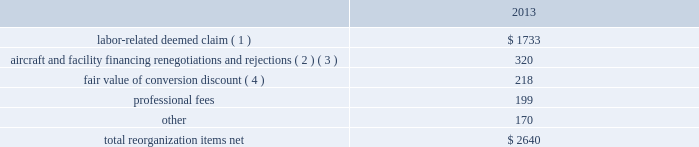Table of contents interest expense , net of capitalized interest decreased $ 129 million , or 18.1% ( 18.1 % ) , in 2014 from the 2013 period primarily due to a $ 63 million decrease in special charges recognized period-over-period as further described below , as well as refinancing activities that resulted in $ 65 million less interest expense recognized in 2014 .
In 2014 , american recognized $ 29 million of special charges relating to non-cash interest accretion on bankruptcy settlement obligations .
In 2013 , american recognized $ 48 million of special charges relating to post-petition interest expense on unsecured obligations pursuant to the plan and penalty interest related to american 2019s 10.5% ( 10.5 % ) secured notes and 7.50% ( 7.50 % ) senior secured notes .
In addition , in 2013 american recorded special charges of $ 44 million for debt extinguishment costs incurred as a result of the repayment of certain aircraft secured indebtedness , including cash interest charges and non-cash write offs of unamortized debt issuance costs .
As a result of the 2013 refinancing activities and the early extinguishment of american 2019s 7.50% ( 7.50 % ) senior secured notes in 2014 , american recognized $ 65 million less interest expense in 2014 as compared to the 2013 period .
Other nonoperating expense , net of $ 153 million in 2014 consisted principally of net foreign currency losses of $ 92 million and early debt extinguishment charges of $ 48 million .
Other nonoperating expense , net of $ 84 million in 2013 consisted principally of net foreign currency losses of $ 55 million and early debt extinguishment charges of $ 29 million .
Other nonoperating expense , net increased $ 69 million , or 81.0% ( 81.0 % ) , during 2014 primarily due to special charges recognized as a result of early debt extinguishment and an increase in foreign currency losses driven by the strengthening of the u.s .
Dollar in foreign currency transactions , principally in latin american markets .
American recorded a $ 43 million special charge for venezuelan foreign currency losses in 2014 .
See part ii , item 7a .
Quantitative and qualitative disclosures about market risk for further discussion of our cash held in venezuelan bolivars .
In addition , american 2019s nonoperating special items included $ 48 million in special charges in the 2014 primarily related to the early extinguishment of american 2019s 7.50% ( 7.50 % ) senior secured notes and other indebtedness .
Reorganization items , net reorganization items refer to revenues , expenses ( including professional fees ) , realized gains and losses and provisions for losses that are realized or incurred as a direct result of the chapter 11 cases .
The table summarizes the components included in reorganization items , net on american 2019s consolidated statement of operations for the year ended december 31 , 2013 ( in millions ) : .
( 1 ) in exchange for employees 2019 contributions to the successful reorganization , including agreeing to reductions in pay and benefits , american agreed in the plan to provide each employee group a deemed claim , which was used to provide a distribution of a portion of the equity of the reorganized entity to those employees .
Each employee group received a deemed claim amount based upon a portion of the value of cost savings provided by that group through reductions to pay and benefits as well as through certain work rule changes .
The total value of this deemed claim was approximately $ 1.7 billion .
( 2 ) amounts include allowed claims ( claims approved by the bankruptcy court ) and estimated allowed claims relating to ( i ) the rejection or modification of financings related to aircraft and ( ii ) entry of orders treated as unsecured claims with respect to facility agreements supporting certain issuances of special facility revenue bonds .
The debtors recorded an estimated claim associated with the rejection or modification of a financing or facility agreement when the applicable motion was filed with the bankruptcy court to reject or modify .
What percentage of total reorganization items net consisted of aircraft and facility financing renegotiations and rejections? 
Computations: (320 / 2640)
Answer: 0.12121. Table of contents interest expense , net of capitalized interest decreased $ 129 million , or 18.1% ( 18.1 % ) , in 2014 from the 2013 period primarily due to a $ 63 million decrease in special charges recognized period-over-period as further described below , as well as refinancing activities that resulted in $ 65 million less interest expense recognized in 2014 .
In 2014 , american recognized $ 29 million of special charges relating to non-cash interest accretion on bankruptcy settlement obligations .
In 2013 , american recognized $ 48 million of special charges relating to post-petition interest expense on unsecured obligations pursuant to the plan and penalty interest related to american 2019s 10.5% ( 10.5 % ) secured notes and 7.50% ( 7.50 % ) senior secured notes .
In addition , in 2013 american recorded special charges of $ 44 million for debt extinguishment costs incurred as a result of the repayment of certain aircraft secured indebtedness , including cash interest charges and non-cash write offs of unamortized debt issuance costs .
As a result of the 2013 refinancing activities and the early extinguishment of american 2019s 7.50% ( 7.50 % ) senior secured notes in 2014 , american recognized $ 65 million less interest expense in 2014 as compared to the 2013 period .
Other nonoperating expense , net of $ 153 million in 2014 consisted principally of net foreign currency losses of $ 92 million and early debt extinguishment charges of $ 48 million .
Other nonoperating expense , net of $ 84 million in 2013 consisted principally of net foreign currency losses of $ 55 million and early debt extinguishment charges of $ 29 million .
Other nonoperating expense , net increased $ 69 million , or 81.0% ( 81.0 % ) , during 2014 primarily due to special charges recognized as a result of early debt extinguishment and an increase in foreign currency losses driven by the strengthening of the u.s .
Dollar in foreign currency transactions , principally in latin american markets .
American recorded a $ 43 million special charge for venezuelan foreign currency losses in 2014 .
See part ii , item 7a .
Quantitative and qualitative disclosures about market risk for further discussion of our cash held in venezuelan bolivars .
In addition , american 2019s nonoperating special items included $ 48 million in special charges in the 2014 primarily related to the early extinguishment of american 2019s 7.50% ( 7.50 % ) senior secured notes and other indebtedness .
Reorganization items , net reorganization items refer to revenues , expenses ( including professional fees ) , realized gains and losses and provisions for losses that are realized or incurred as a direct result of the chapter 11 cases .
The table summarizes the components included in reorganization items , net on american 2019s consolidated statement of operations for the year ended december 31 , 2013 ( in millions ) : .
( 1 ) in exchange for employees 2019 contributions to the successful reorganization , including agreeing to reductions in pay and benefits , american agreed in the plan to provide each employee group a deemed claim , which was used to provide a distribution of a portion of the equity of the reorganized entity to those employees .
Each employee group received a deemed claim amount based upon a portion of the value of cost savings provided by that group through reductions to pay and benefits as well as through certain work rule changes .
The total value of this deemed claim was approximately $ 1.7 billion .
( 2 ) amounts include allowed claims ( claims approved by the bankruptcy court ) and estimated allowed claims relating to ( i ) the rejection or modification of financings related to aircraft and ( ii ) entry of orders treated as unsecured claims with respect to facility agreements supporting certain issuances of special facility revenue bonds .
The debtors recorded an estimated claim associated with the rejection or modification of a financing or facility agreement when the applicable motion was filed with the bankruptcy court to reject or modify .
What is the percent of the labor-related deemed claim to the total re-organization costs in 2013? 
Rationale: the percent is the amount divided by the total amount multiply by 100
Computations: (1733 / 2640)
Answer: 0.65644. 